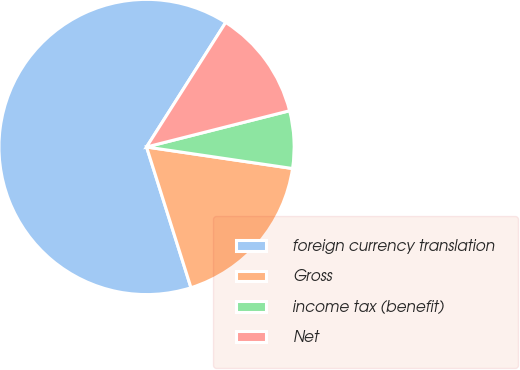Convert chart to OTSL. <chart><loc_0><loc_0><loc_500><loc_500><pie_chart><fcel>foreign currency translation<fcel>Gross<fcel>income tax (benefit)<fcel>Net<nl><fcel>63.88%<fcel>17.8%<fcel>6.28%<fcel>12.04%<nl></chart> 